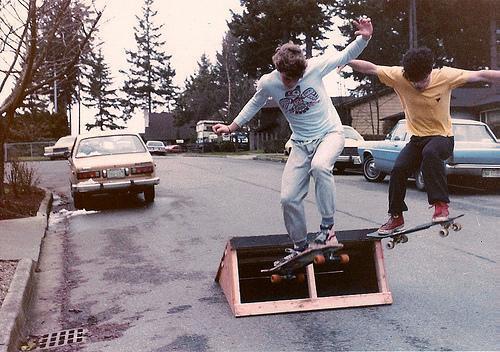How many boys are there?
Give a very brief answer. 2. How many skateboards are there?
Give a very brief answer. 2. How many people are in the photo?
Give a very brief answer. 2. How many cars can you see?
Give a very brief answer. 2. 